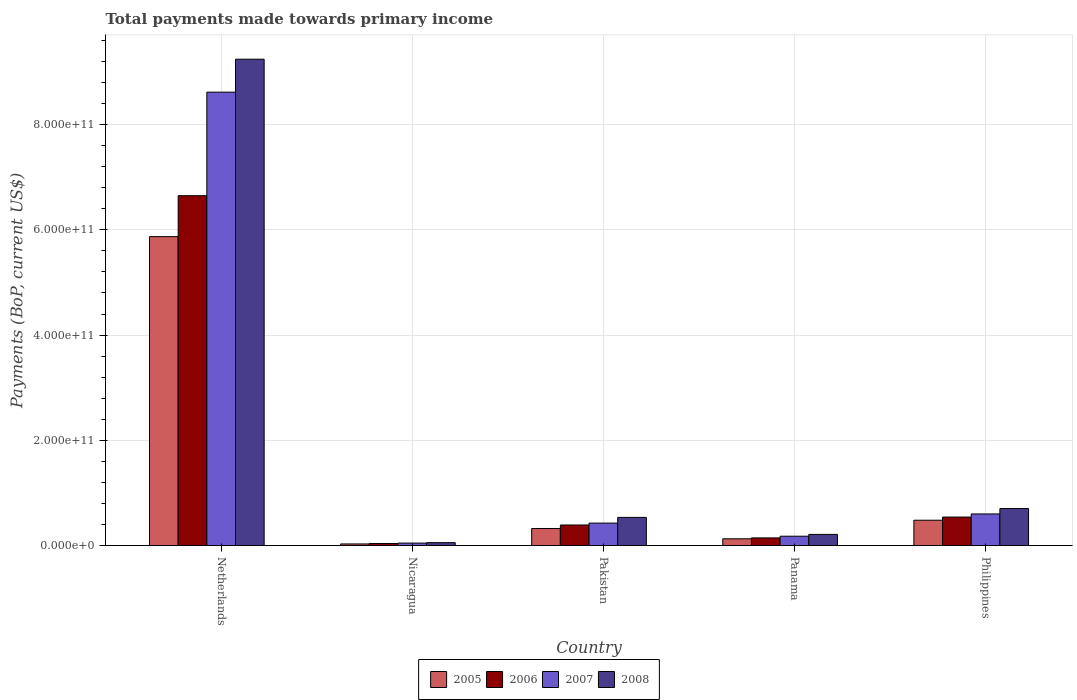How many different coloured bars are there?
Make the answer very short. 4. Are the number of bars on each tick of the X-axis equal?
Provide a succinct answer. Yes. How many bars are there on the 4th tick from the right?
Your response must be concise. 4. What is the label of the 2nd group of bars from the left?
Give a very brief answer. Nicaragua. What is the total payments made towards primary income in 2007 in Panama?
Your answer should be compact. 1.78e+1. Across all countries, what is the maximum total payments made towards primary income in 2007?
Keep it short and to the point. 8.62e+11. Across all countries, what is the minimum total payments made towards primary income in 2006?
Provide a succinct answer. 3.94e+09. In which country was the total payments made towards primary income in 2007 minimum?
Make the answer very short. Nicaragua. What is the total total payments made towards primary income in 2007 in the graph?
Offer a terse response. 9.87e+11. What is the difference between the total payments made towards primary income in 2008 in Nicaragua and that in Philippines?
Your response must be concise. -6.48e+1. What is the difference between the total payments made towards primary income in 2008 in Netherlands and the total payments made towards primary income in 2006 in Panama?
Provide a short and direct response. 9.10e+11. What is the average total payments made towards primary income in 2008 per country?
Provide a short and direct response. 2.15e+11. What is the difference between the total payments made towards primary income of/in 2006 and total payments made towards primary income of/in 2005 in Panama?
Ensure brevity in your answer.  1.66e+09. What is the ratio of the total payments made towards primary income in 2005 in Pakistan to that in Philippines?
Give a very brief answer. 0.67. Is the difference between the total payments made towards primary income in 2006 in Pakistan and Philippines greater than the difference between the total payments made towards primary income in 2005 in Pakistan and Philippines?
Keep it short and to the point. Yes. What is the difference between the highest and the second highest total payments made towards primary income in 2007?
Provide a short and direct response. 8.19e+11. What is the difference between the highest and the lowest total payments made towards primary income in 2005?
Your response must be concise. 5.84e+11. In how many countries, is the total payments made towards primary income in 2005 greater than the average total payments made towards primary income in 2005 taken over all countries?
Ensure brevity in your answer.  1. Is it the case that in every country, the sum of the total payments made towards primary income in 2007 and total payments made towards primary income in 2008 is greater than the total payments made towards primary income in 2005?
Provide a succinct answer. Yes. How many bars are there?
Keep it short and to the point. 20. Are all the bars in the graph horizontal?
Your answer should be very brief. No. What is the difference between two consecutive major ticks on the Y-axis?
Ensure brevity in your answer.  2.00e+11. Are the values on the major ticks of Y-axis written in scientific E-notation?
Provide a short and direct response. Yes. Does the graph contain any zero values?
Your answer should be compact. No. Does the graph contain grids?
Provide a short and direct response. Yes. How are the legend labels stacked?
Keep it short and to the point. Horizontal. What is the title of the graph?
Ensure brevity in your answer.  Total payments made towards primary income. What is the label or title of the X-axis?
Offer a terse response. Country. What is the label or title of the Y-axis?
Offer a very short reply. Payments (BoP, current US$). What is the Payments (BoP, current US$) in 2005 in Netherlands?
Make the answer very short. 5.87e+11. What is the Payments (BoP, current US$) in 2006 in Netherlands?
Ensure brevity in your answer.  6.65e+11. What is the Payments (BoP, current US$) of 2007 in Netherlands?
Your answer should be compact. 8.62e+11. What is the Payments (BoP, current US$) of 2008 in Netherlands?
Give a very brief answer. 9.24e+11. What is the Payments (BoP, current US$) of 2005 in Nicaragua?
Your answer should be very brief. 3.07e+09. What is the Payments (BoP, current US$) of 2006 in Nicaragua?
Offer a very short reply. 3.94e+09. What is the Payments (BoP, current US$) in 2007 in Nicaragua?
Your answer should be very brief. 4.71e+09. What is the Payments (BoP, current US$) of 2008 in Nicaragua?
Give a very brief answer. 5.52e+09. What is the Payments (BoP, current US$) of 2005 in Pakistan?
Give a very brief answer. 3.24e+1. What is the Payments (BoP, current US$) in 2006 in Pakistan?
Offer a very short reply. 3.91e+1. What is the Payments (BoP, current US$) in 2007 in Pakistan?
Provide a succinct answer. 4.27e+1. What is the Payments (BoP, current US$) of 2008 in Pakistan?
Provide a short and direct response. 5.35e+1. What is the Payments (BoP, current US$) of 2005 in Panama?
Offer a very short reply. 1.29e+1. What is the Payments (BoP, current US$) of 2006 in Panama?
Offer a terse response. 1.45e+1. What is the Payments (BoP, current US$) in 2007 in Panama?
Make the answer very short. 1.78e+1. What is the Payments (BoP, current US$) in 2008 in Panama?
Provide a succinct answer. 2.12e+1. What is the Payments (BoP, current US$) of 2005 in Philippines?
Offer a terse response. 4.82e+1. What is the Payments (BoP, current US$) of 2006 in Philippines?
Your answer should be very brief. 5.42e+1. What is the Payments (BoP, current US$) in 2007 in Philippines?
Make the answer very short. 6.01e+1. What is the Payments (BoP, current US$) of 2008 in Philippines?
Your answer should be very brief. 7.03e+1. Across all countries, what is the maximum Payments (BoP, current US$) of 2005?
Offer a terse response. 5.87e+11. Across all countries, what is the maximum Payments (BoP, current US$) in 2006?
Your answer should be very brief. 6.65e+11. Across all countries, what is the maximum Payments (BoP, current US$) in 2007?
Your answer should be very brief. 8.62e+11. Across all countries, what is the maximum Payments (BoP, current US$) of 2008?
Make the answer very short. 9.24e+11. Across all countries, what is the minimum Payments (BoP, current US$) of 2005?
Keep it short and to the point. 3.07e+09. Across all countries, what is the minimum Payments (BoP, current US$) of 2006?
Your answer should be very brief. 3.94e+09. Across all countries, what is the minimum Payments (BoP, current US$) in 2007?
Your answer should be very brief. 4.71e+09. Across all countries, what is the minimum Payments (BoP, current US$) of 2008?
Give a very brief answer. 5.52e+09. What is the total Payments (BoP, current US$) in 2005 in the graph?
Give a very brief answer. 6.84e+11. What is the total Payments (BoP, current US$) of 2006 in the graph?
Your response must be concise. 7.77e+11. What is the total Payments (BoP, current US$) in 2007 in the graph?
Provide a succinct answer. 9.87e+11. What is the total Payments (BoP, current US$) in 2008 in the graph?
Ensure brevity in your answer.  1.07e+12. What is the difference between the Payments (BoP, current US$) of 2005 in Netherlands and that in Nicaragua?
Make the answer very short. 5.84e+11. What is the difference between the Payments (BoP, current US$) in 2006 in Netherlands and that in Nicaragua?
Your answer should be very brief. 6.61e+11. What is the difference between the Payments (BoP, current US$) in 2007 in Netherlands and that in Nicaragua?
Provide a succinct answer. 8.57e+11. What is the difference between the Payments (BoP, current US$) of 2008 in Netherlands and that in Nicaragua?
Your answer should be very brief. 9.19e+11. What is the difference between the Payments (BoP, current US$) of 2005 in Netherlands and that in Pakistan?
Give a very brief answer. 5.55e+11. What is the difference between the Payments (BoP, current US$) of 2006 in Netherlands and that in Pakistan?
Your answer should be compact. 6.26e+11. What is the difference between the Payments (BoP, current US$) of 2007 in Netherlands and that in Pakistan?
Your answer should be very brief. 8.19e+11. What is the difference between the Payments (BoP, current US$) in 2008 in Netherlands and that in Pakistan?
Offer a terse response. 8.71e+11. What is the difference between the Payments (BoP, current US$) in 2005 in Netherlands and that in Panama?
Make the answer very short. 5.74e+11. What is the difference between the Payments (BoP, current US$) in 2006 in Netherlands and that in Panama?
Give a very brief answer. 6.50e+11. What is the difference between the Payments (BoP, current US$) of 2007 in Netherlands and that in Panama?
Offer a terse response. 8.44e+11. What is the difference between the Payments (BoP, current US$) of 2008 in Netherlands and that in Panama?
Offer a terse response. 9.03e+11. What is the difference between the Payments (BoP, current US$) in 2005 in Netherlands and that in Philippines?
Provide a succinct answer. 5.39e+11. What is the difference between the Payments (BoP, current US$) in 2006 in Netherlands and that in Philippines?
Make the answer very short. 6.11e+11. What is the difference between the Payments (BoP, current US$) of 2007 in Netherlands and that in Philippines?
Your response must be concise. 8.02e+11. What is the difference between the Payments (BoP, current US$) of 2008 in Netherlands and that in Philippines?
Provide a succinct answer. 8.54e+11. What is the difference between the Payments (BoP, current US$) in 2005 in Nicaragua and that in Pakistan?
Offer a terse response. -2.94e+1. What is the difference between the Payments (BoP, current US$) of 2006 in Nicaragua and that in Pakistan?
Offer a terse response. -3.52e+1. What is the difference between the Payments (BoP, current US$) in 2007 in Nicaragua and that in Pakistan?
Ensure brevity in your answer.  -3.80e+1. What is the difference between the Payments (BoP, current US$) in 2008 in Nicaragua and that in Pakistan?
Provide a succinct answer. -4.80e+1. What is the difference between the Payments (BoP, current US$) of 2005 in Nicaragua and that in Panama?
Your answer should be compact. -9.81e+09. What is the difference between the Payments (BoP, current US$) in 2006 in Nicaragua and that in Panama?
Ensure brevity in your answer.  -1.06e+1. What is the difference between the Payments (BoP, current US$) in 2007 in Nicaragua and that in Panama?
Offer a terse response. -1.31e+1. What is the difference between the Payments (BoP, current US$) in 2008 in Nicaragua and that in Panama?
Your answer should be very brief. -1.57e+1. What is the difference between the Payments (BoP, current US$) of 2005 in Nicaragua and that in Philippines?
Your answer should be compact. -4.51e+1. What is the difference between the Payments (BoP, current US$) of 2006 in Nicaragua and that in Philippines?
Keep it short and to the point. -5.02e+1. What is the difference between the Payments (BoP, current US$) in 2007 in Nicaragua and that in Philippines?
Offer a very short reply. -5.54e+1. What is the difference between the Payments (BoP, current US$) of 2008 in Nicaragua and that in Philippines?
Your answer should be compact. -6.48e+1. What is the difference between the Payments (BoP, current US$) in 2005 in Pakistan and that in Panama?
Your answer should be very brief. 1.96e+1. What is the difference between the Payments (BoP, current US$) of 2006 in Pakistan and that in Panama?
Provide a succinct answer. 2.45e+1. What is the difference between the Payments (BoP, current US$) of 2007 in Pakistan and that in Panama?
Offer a terse response. 2.49e+1. What is the difference between the Payments (BoP, current US$) in 2008 in Pakistan and that in Panama?
Provide a short and direct response. 3.23e+1. What is the difference between the Payments (BoP, current US$) of 2005 in Pakistan and that in Philippines?
Ensure brevity in your answer.  -1.57e+1. What is the difference between the Payments (BoP, current US$) of 2006 in Pakistan and that in Philippines?
Offer a very short reply. -1.51e+1. What is the difference between the Payments (BoP, current US$) in 2007 in Pakistan and that in Philippines?
Ensure brevity in your answer.  -1.74e+1. What is the difference between the Payments (BoP, current US$) in 2008 in Pakistan and that in Philippines?
Keep it short and to the point. -1.68e+1. What is the difference between the Payments (BoP, current US$) in 2005 in Panama and that in Philippines?
Your answer should be compact. -3.53e+1. What is the difference between the Payments (BoP, current US$) of 2006 in Panama and that in Philippines?
Provide a short and direct response. -3.96e+1. What is the difference between the Payments (BoP, current US$) of 2007 in Panama and that in Philippines?
Offer a very short reply. -4.23e+1. What is the difference between the Payments (BoP, current US$) of 2008 in Panama and that in Philippines?
Provide a short and direct response. -4.91e+1. What is the difference between the Payments (BoP, current US$) of 2005 in Netherlands and the Payments (BoP, current US$) of 2006 in Nicaragua?
Offer a terse response. 5.83e+11. What is the difference between the Payments (BoP, current US$) in 2005 in Netherlands and the Payments (BoP, current US$) in 2007 in Nicaragua?
Provide a short and direct response. 5.82e+11. What is the difference between the Payments (BoP, current US$) of 2005 in Netherlands and the Payments (BoP, current US$) of 2008 in Nicaragua?
Your response must be concise. 5.82e+11. What is the difference between the Payments (BoP, current US$) of 2006 in Netherlands and the Payments (BoP, current US$) of 2007 in Nicaragua?
Give a very brief answer. 6.60e+11. What is the difference between the Payments (BoP, current US$) of 2006 in Netherlands and the Payments (BoP, current US$) of 2008 in Nicaragua?
Offer a terse response. 6.59e+11. What is the difference between the Payments (BoP, current US$) of 2007 in Netherlands and the Payments (BoP, current US$) of 2008 in Nicaragua?
Provide a short and direct response. 8.56e+11. What is the difference between the Payments (BoP, current US$) of 2005 in Netherlands and the Payments (BoP, current US$) of 2006 in Pakistan?
Your answer should be very brief. 5.48e+11. What is the difference between the Payments (BoP, current US$) of 2005 in Netherlands and the Payments (BoP, current US$) of 2007 in Pakistan?
Provide a succinct answer. 5.44e+11. What is the difference between the Payments (BoP, current US$) of 2005 in Netherlands and the Payments (BoP, current US$) of 2008 in Pakistan?
Your answer should be compact. 5.33e+11. What is the difference between the Payments (BoP, current US$) in 2006 in Netherlands and the Payments (BoP, current US$) in 2007 in Pakistan?
Offer a terse response. 6.22e+11. What is the difference between the Payments (BoP, current US$) in 2006 in Netherlands and the Payments (BoP, current US$) in 2008 in Pakistan?
Offer a terse response. 6.11e+11. What is the difference between the Payments (BoP, current US$) of 2007 in Netherlands and the Payments (BoP, current US$) of 2008 in Pakistan?
Make the answer very short. 8.08e+11. What is the difference between the Payments (BoP, current US$) in 2005 in Netherlands and the Payments (BoP, current US$) in 2006 in Panama?
Ensure brevity in your answer.  5.72e+11. What is the difference between the Payments (BoP, current US$) of 2005 in Netherlands and the Payments (BoP, current US$) of 2007 in Panama?
Your answer should be very brief. 5.69e+11. What is the difference between the Payments (BoP, current US$) in 2005 in Netherlands and the Payments (BoP, current US$) in 2008 in Panama?
Your response must be concise. 5.66e+11. What is the difference between the Payments (BoP, current US$) in 2006 in Netherlands and the Payments (BoP, current US$) in 2007 in Panama?
Offer a very short reply. 6.47e+11. What is the difference between the Payments (BoP, current US$) in 2006 in Netherlands and the Payments (BoP, current US$) in 2008 in Panama?
Ensure brevity in your answer.  6.44e+11. What is the difference between the Payments (BoP, current US$) in 2007 in Netherlands and the Payments (BoP, current US$) in 2008 in Panama?
Provide a short and direct response. 8.40e+11. What is the difference between the Payments (BoP, current US$) in 2005 in Netherlands and the Payments (BoP, current US$) in 2006 in Philippines?
Your answer should be very brief. 5.33e+11. What is the difference between the Payments (BoP, current US$) of 2005 in Netherlands and the Payments (BoP, current US$) of 2007 in Philippines?
Make the answer very short. 5.27e+11. What is the difference between the Payments (BoP, current US$) of 2005 in Netherlands and the Payments (BoP, current US$) of 2008 in Philippines?
Keep it short and to the point. 5.17e+11. What is the difference between the Payments (BoP, current US$) of 2006 in Netherlands and the Payments (BoP, current US$) of 2007 in Philippines?
Your response must be concise. 6.05e+11. What is the difference between the Payments (BoP, current US$) of 2006 in Netherlands and the Payments (BoP, current US$) of 2008 in Philippines?
Provide a short and direct response. 5.94e+11. What is the difference between the Payments (BoP, current US$) of 2007 in Netherlands and the Payments (BoP, current US$) of 2008 in Philippines?
Keep it short and to the point. 7.91e+11. What is the difference between the Payments (BoP, current US$) of 2005 in Nicaragua and the Payments (BoP, current US$) of 2006 in Pakistan?
Provide a succinct answer. -3.60e+1. What is the difference between the Payments (BoP, current US$) of 2005 in Nicaragua and the Payments (BoP, current US$) of 2007 in Pakistan?
Provide a succinct answer. -3.96e+1. What is the difference between the Payments (BoP, current US$) of 2005 in Nicaragua and the Payments (BoP, current US$) of 2008 in Pakistan?
Your answer should be very brief. -5.05e+1. What is the difference between the Payments (BoP, current US$) in 2006 in Nicaragua and the Payments (BoP, current US$) in 2007 in Pakistan?
Provide a succinct answer. -3.87e+1. What is the difference between the Payments (BoP, current US$) in 2006 in Nicaragua and the Payments (BoP, current US$) in 2008 in Pakistan?
Ensure brevity in your answer.  -4.96e+1. What is the difference between the Payments (BoP, current US$) of 2007 in Nicaragua and the Payments (BoP, current US$) of 2008 in Pakistan?
Make the answer very short. -4.88e+1. What is the difference between the Payments (BoP, current US$) of 2005 in Nicaragua and the Payments (BoP, current US$) of 2006 in Panama?
Your response must be concise. -1.15e+1. What is the difference between the Payments (BoP, current US$) in 2005 in Nicaragua and the Payments (BoP, current US$) in 2007 in Panama?
Offer a very short reply. -1.47e+1. What is the difference between the Payments (BoP, current US$) in 2005 in Nicaragua and the Payments (BoP, current US$) in 2008 in Panama?
Give a very brief answer. -1.81e+1. What is the difference between the Payments (BoP, current US$) of 2006 in Nicaragua and the Payments (BoP, current US$) of 2007 in Panama?
Keep it short and to the point. -1.38e+1. What is the difference between the Payments (BoP, current US$) in 2006 in Nicaragua and the Payments (BoP, current US$) in 2008 in Panama?
Give a very brief answer. -1.73e+1. What is the difference between the Payments (BoP, current US$) of 2007 in Nicaragua and the Payments (BoP, current US$) of 2008 in Panama?
Give a very brief answer. -1.65e+1. What is the difference between the Payments (BoP, current US$) of 2005 in Nicaragua and the Payments (BoP, current US$) of 2006 in Philippines?
Make the answer very short. -5.11e+1. What is the difference between the Payments (BoP, current US$) in 2005 in Nicaragua and the Payments (BoP, current US$) in 2007 in Philippines?
Your answer should be very brief. -5.70e+1. What is the difference between the Payments (BoP, current US$) of 2005 in Nicaragua and the Payments (BoP, current US$) of 2008 in Philippines?
Provide a short and direct response. -6.72e+1. What is the difference between the Payments (BoP, current US$) of 2006 in Nicaragua and the Payments (BoP, current US$) of 2007 in Philippines?
Make the answer very short. -5.61e+1. What is the difference between the Payments (BoP, current US$) of 2006 in Nicaragua and the Payments (BoP, current US$) of 2008 in Philippines?
Your response must be concise. -6.64e+1. What is the difference between the Payments (BoP, current US$) in 2007 in Nicaragua and the Payments (BoP, current US$) in 2008 in Philippines?
Offer a terse response. -6.56e+1. What is the difference between the Payments (BoP, current US$) of 2005 in Pakistan and the Payments (BoP, current US$) of 2006 in Panama?
Offer a very short reply. 1.79e+1. What is the difference between the Payments (BoP, current US$) of 2005 in Pakistan and the Payments (BoP, current US$) of 2007 in Panama?
Provide a short and direct response. 1.47e+1. What is the difference between the Payments (BoP, current US$) of 2005 in Pakistan and the Payments (BoP, current US$) of 2008 in Panama?
Provide a succinct answer. 1.12e+1. What is the difference between the Payments (BoP, current US$) in 2006 in Pakistan and the Payments (BoP, current US$) in 2007 in Panama?
Provide a short and direct response. 2.13e+1. What is the difference between the Payments (BoP, current US$) of 2006 in Pakistan and the Payments (BoP, current US$) of 2008 in Panama?
Keep it short and to the point. 1.79e+1. What is the difference between the Payments (BoP, current US$) of 2007 in Pakistan and the Payments (BoP, current US$) of 2008 in Panama?
Your answer should be very brief. 2.15e+1. What is the difference between the Payments (BoP, current US$) in 2005 in Pakistan and the Payments (BoP, current US$) in 2006 in Philippines?
Keep it short and to the point. -2.17e+1. What is the difference between the Payments (BoP, current US$) in 2005 in Pakistan and the Payments (BoP, current US$) in 2007 in Philippines?
Ensure brevity in your answer.  -2.76e+1. What is the difference between the Payments (BoP, current US$) in 2005 in Pakistan and the Payments (BoP, current US$) in 2008 in Philippines?
Provide a succinct answer. -3.79e+1. What is the difference between the Payments (BoP, current US$) in 2006 in Pakistan and the Payments (BoP, current US$) in 2007 in Philippines?
Offer a very short reply. -2.10e+1. What is the difference between the Payments (BoP, current US$) in 2006 in Pakistan and the Payments (BoP, current US$) in 2008 in Philippines?
Ensure brevity in your answer.  -3.12e+1. What is the difference between the Payments (BoP, current US$) in 2007 in Pakistan and the Payments (BoP, current US$) in 2008 in Philippines?
Provide a succinct answer. -2.76e+1. What is the difference between the Payments (BoP, current US$) in 2005 in Panama and the Payments (BoP, current US$) in 2006 in Philippines?
Your response must be concise. -4.13e+1. What is the difference between the Payments (BoP, current US$) in 2005 in Panama and the Payments (BoP, current US$) in 2007 in Philippines?
Make the answer very short. -4.72e+1. What is the difference between the Payments (BoP, current US$) of 2005 in Panama and the Payments (BoP, current US$) of 2008 in Philippines?
Offer a terse response. -5.74e+1. What is the difference between the Payments (BoP, current US$) of 2006 in Panama and the Payments (BoP, current US$) of 2007 in Philippines?
Offer a terse response. -4.55e+1. What is the difference between the Payments (BoP, current US$) in 2006 in Panama and the Payments (BoP, current US$) in 2008 in Philippines?
Your answer should be very brief. -5.58e+1. What is the difference between the Payments (BoP, current US$) of 2007 in Panama and the Payments (BoP, current US$) of 2008 in Philippines?
Provide a succinct answer. -5.25e+1. What is the average Payments (BoP, current US$) in 2005 per country?
Give a very brief answer. 1.37e+11. What is the average Payments (BoP, current US$) in 2006 per country?
Your response must be concise. 1.55e+11. What is the average Payments (BoP, current US$) of 2007 per country?
Offer a terse response. 1.97e+11. What is the average Payments (BoP, current US$) in 2008 per country?
Keep it short and to the point. 2.15e+11. What is the difference between the Payments (BoP, current US$) in 2005 and Payments (BoP, current US$) in 2006 in Netherlands?
Provide a short and direct response. -7.78e+1. What is the difference between the Payments (BoP, current US$) in 2005 and Payments (BoP, current US$) in 2007 in Netherlands?
Your answer should be compact. -2.75e+11. What is the difference between the Payments (BoP, current US$) of 2005 and Payments (BoP, current US$) of 2008 in Netherlands?
Offer a very short reply. -3.37e+11. What is the difference between the Payments (BoP, current US$) in 2006 and Payments (BoP, current US$) in 2007 in Netherlands?
Keep it short and to the point. -1.97e+11. What is the difference between the Payments (BoP, current US$) in 2006 and Payments (BoP, current US$) in 2008 in Netherlands?
Your answer should be compact. -2.59e+11. What is the difference between the Payments (BoP, current US$) in 2007 and Payments (BoP, current US$) in 2008 in Netherlands?
Provide a short and direct response. -6.26e+1. What is the difference between the Payments (BoP, current US$) of 2005 and Payments (BoP, current US$) of 2006 in Nicaragua?
Keep it short and to the point. -8.67e+08. What is the difference between the Payments (BoP, current US$) of 2005 and Payments (BoP, current US$) of 2007 in Nicaragua?
Offer a terse response. -1.64e+09. What is the difference between the Payments (BoP, current US$) of 2005 and Payments (BoP, current US$) of 2008 in Nicaragua?
Your answer should be very brief. -2.44e+09. What is the difference between the Payments (BoP, current US$) of 2006 and Payments (BoP, current US$) of 2007 in Nicaragua?
Your response must be concise. -7.70e+08. What is the difference between the Payments (BoP, current US$) in 2006 and Payments (BoP, current US$) in 2008 in Nicaragua?
Ensure brevity in your answer.  -1.58e+09. What is the difference between the Payments (BoP, current US$) in 2007 and Payments (BoP, current US$) in 2008 in Nicaragua?
Offer a terse response. -8.07e+08. What is the difference between the Payments (BoP, current US$) of 2005 and Payments (BoP, current US$) of 2006 in Pakistan?
Make the answer very short. -6.65e+09. What is the difference between the Payments (BoP, current US$) in 2005 and Payments (BoP, current US$) in 2007 in Pakistan?
Ensure brevity in your answer.  -1.02e+1. What is the difference between the Payments (BoP, current US$) of 2005 and Payments (BoP, current US$) of 2008 in Pakistan?
Your answer should be compact. -2.11e+1. What is the difference between the Payments (BoP, current US$) of 2006 and Payments (BoP, current US$) of 2007 in Pakistan?
Make the answer very short. -3.59e+09. What is the difference between the Payments (BoP, current US$) in 2006 and Payments (BoP, current US$) in 2008 in Pakistan?
Your response must be concise. -1.45e+1. What is the difference between the Payments (BoP, current US$) of 2007 and Payments (BoP, current US$) of 2008 in Pakistan?
Offer a terse response. -1.09e+1. What is the difference between the Payments (BoP, current US$) of 2005 and Payments (BoP, current US$) of 2006 in Panama?
Your response must be concise. -1.66e+09. What is the difference between the Payments (BoP, current US$) of 2005 and Payments (BoP, current US$) of 2007 in Panama?
Ensure brevity in your answer.  -4.90e+09. What is the difference between the Payments (BoP, current US$) in 2005 and Payments (BoP, current US$) in 2008 in Panama?
Your response must be concise. -8.33e+09. What is the difference between the Payments (BoP, current US$) in 2006 and Payments (BoP, current US$) in 2007 in Panama?
Provide a short and direct response. -3.24e+09. What is the difference between the Payments (BoP, current US$) of 2006 and Payments (BoP, current US$) of 2008 in Panama?
Make the answer very short. -6.67e+09. What is the difference between the Payments (BoP, current US$) in 2007 and Payments (BoP, current US$) in 2008 in Panama?
Keep it short and to the point. -3.43e+09. What is the difference between the Payments (BoP, current US$) in 2005 and Payments (BoP, current US$) in 2006 in Philippines?
Make the answer very short. -6.00e+09. What is the difference between the Payments (BoP, current US$) of 2005 and Payments (BoP, current US$) of 2007 in Philippines?
Give a very brief answer. -1.19e+1. What is the difference between the Payments (BoP, current US$) of 2005 and Payments (BoP, current US$) of 2008 in Philippines?
Your answer should be very brief. -2.22e+1. What is the difference between the Payments (BoP, current US$) of 2006 and Payments (BoP, current US$) of 2007 in Philippines?
Offer a terse response. -5.92e+09. What is the difference between the Payments (BoP, current US$) in 2006 and Payments (BoP, current US$) in 2008 in Philippines?
Your response must be concise. -1.62e+1. What is the difference between the Payments (BoP, current US$) of 2007 and Payments (BoP, current US$) of 2008 in Philippines?
Ensure brevity in your answer.  -1.02e+1. What is the ratio of the Payments (BoP, current US$) of 2005 in Netherlands to that in Nicaragua?
Keep it short and to the point. 190.91. What is the ratio of the Payments (BoP, current US$) in 2006 in Netherlands to that in Nicaragua?
Ensure brevity in your answer.  168.63. What is the ratio of the Payments (BoP, current US$) of 2007 in Netherlands to that in Nicaragua?
Offer a terse response. 182.84. What is the ratio of the Payments (BoP, current US$) in 2008 in Netherlands to that in Nicaragua?
Your response must be concise. 167.45. What is the ratio of the Payments (BoP, current US$) in 2005 in Netherlands to that in Pakistan?
Offer a terse response. 18.09. What is the ratio of the Payments (BoP, current US$) of 2006 in Netherlands to that in Pakistan?
Give a very brief answer. 17. What is the ratio of the Payments (BoP, current US$) in 2007 in Netherlands to that in Pakistan?
Make the answer very short. 20.18. What is the ratio of the Payments (BoP, current US$) of 2008 in Netherlands to that in Pakistan?
Your answer should be very brief. 17.26. What is the ratio of the Payments (BoP, current US$) in 2005 in Netherlands to that in Panama?
Provide a short and direct response. 45.57. What is the ratio of the Payments (BoP, current US$) in 2006 in Netherlands to that in Panama?
Keep it short and to the point. 45.7. What is the ratio of the Payments (BoP, current US$) of 2007 in Netherlands to that in Panama?
Your answer should be very brief. 48.45. What is the ratio of the Payments (BoP, current US$) of 2008 in Netherlands to that in Panama?
Offer a terse response. 43.56. What is the ratio of the Payments (BoP, current US$) of 2005 in Netherlands to that in Philippines?
Offer a very short reply. 12.19. What is the ratio of the Payments (BoP, current US$) of 2006 in Netherlands to that in Philippines?
Provide a succinct answer. 12.28. What is the ratio of the Payments (BoP, current US$) of 2007 in Netherlands to that in Philippines?
Provide a short and direct response. 14.34. What is the ratio of the Payments (BoP, current US$) in 2008 in Netherlands to that in Philippines?
Provide a succinct answer. 13.14. What is the ratio of the Payments (BoP, current US$) of 2005 in Nicaragua to that in Pakistan?
Offer a terse response. 0.09. What is the ratio of the Payments (BoP, current US$) in 2006 in Nicaragua to that in Pakistan?
Ensure brevity in your answer.  0.1. What is the ratio of the Payments (BoP, current US$) of 2007 in Nicaragua to that in Pakistan?
Keep it short and to the point. 0.11. What is the ratio of the Payments (BoP, current US$) in 2008 in Nicaragua to that in Pakistan?
Make the answer very short. 0.1. What is the ratio of the Payments (BoP, current US$) in 2005 in Nicaragua to that in Panama?
Provide a succinct answer. 0.24. What is the ratio of the Payments (BoP, current US$) in 2006 in Nicaragua to that in Panama?
Provide a short and direct response. 0.27. What is the ratio of the Payments (BoP, current US$) in 2007 in Nicaragua to that in Panama?
Provide a succinct answer. 0.27. What is the ratio of the Payments (BoP, current US$) of 2008 in Nicaragua to that in Panama?
Provide a succinct answer. 0.26. What is the ratio of the Payments (BoP, current US$) of 2005 in Nicaragua to that in Philippines?
Your answer should be very brief. 0.06. What is the ratio of the Payments (BoP, current US$) in 2006 in Nicaragua to that in Philippines?
Keep it short and to the point. 0.07. What is the ratio of the Payments (BoP, current US$) in 2007 in Nicaragua to that in Philippines?
Offer a very short reply. 0.08. What is the ratio of the Payments (BoP, current US$) in 2008 in Nicaragua to that in Philippines?
Make the answer very short. 0.08. What is the ratio of the Payments (BoP, current US$) of 2005 in Pakistan to that in Panama?
Give a very brief answer. 2.52. What is the ratio of the Payments (BoP, current US$) in 2006 in Pakistan to that in Panama?
Offer a very short reply. 2.69. What is the ratio of the Payments (BoP, current US$) in 2007 in Pakistan to that in Panama?
Give a very brief answer. 2.4. What is the ratio of the Payments (BoP, current US$) in 2008 in Pakistan to that in Panama?
Your answer should be very brief. 2.52. What is the ratio of the Payments (BoP, current US$) in 2005 in Pakistan to that in Philippines?
Offer a terse response. 0.67. What is the ratio of the Payments (BoP, current US$) of 2006 in Pakistan to that in Philippines?
Keep it short and to the point. 0.72. What is the ratio of the Payments (BoP, current US$) of 2007 in Pakistan to that in Philippines?
Your response must be concise. 0.71. What is the ratio of the Payments (BoP, current US$) in 2008 in Pakistan to that in Philippines?
Provide a succinct answer. 0.76. What is the ratio of the Payments (BoP, current US$) in 2005 in Panama to that in Philippines?
Your answer should be compact. 0.27. What is the ratio of the Payments (BoP, current US$) in 2006 in Panama to that in Philippines?
Keep it short and to the point. 0.27. What is the ratio of the Payments (BoP, current US$) in 2007 in Panama to that in Philippines?
Keep it short and to the point. 0.3. What is the ratio of the Payments (BoP, current US$) of 2008 in Panama to that in Philippines?
Keep it short and to the point. 0.3. What is the difference between the highest and the second highest Payments (BoP, current US$) of 2005?
Ensure brevity in your answer.  5.39e+11. What is the difference between the highest and the second highest Payments (BoP, current US$) of 2006?
Your answer should be compact. 6.11e+11. What is the difference between the highest and the second highest Payments (BoP, current US$) of 2007?
Make the answer very short. 8.02e+11. What is the difference between the highest and the second highest Payments (BoP, current US$) of 2008?
Give a very brief answer. 8.54e+11. What is the difference between the highest and the lowest Payments (BoP, current US$) of 2005?
Make the answer very short. 5.84e+11. What is the difference between the highest and the lowest Payments (BoP, current US$) of 2006?
Make the answer very short. 6.61e+11. What is the difference between the highest and the lowest Payments (BoP, current US$) in 2007?
Offer a terse response. 8.57e+11. What is the difference between the highest and the lowest Payments (BoP, current US$) of 2008?
Make the answer very short. 9.19e+11. 